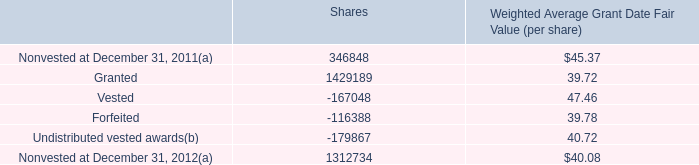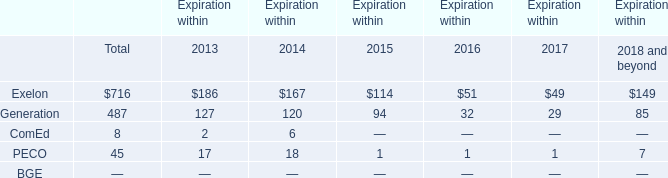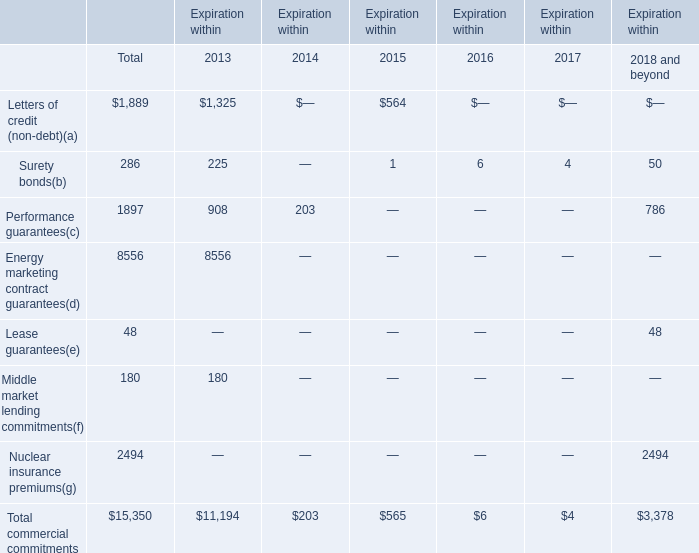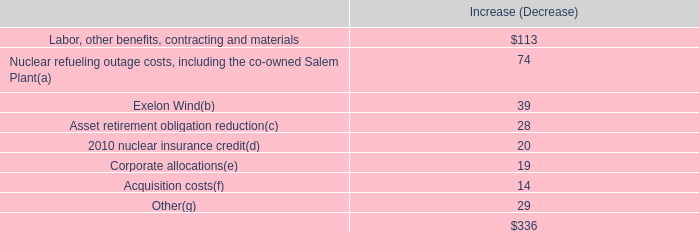What is the total amount of Undistributed vested awards of Shares, and Energy marketing contract guarantees of Expiration within 2013 ? 
Computations: (179867.0 + 8556.0)
Answer: 188423.0. 